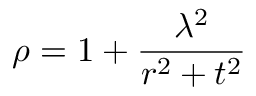Convert formula to latex. <formula><loc_0><loc_0><loc_500><loc_500>\rho = 1 + \frac { \lambda ^ { 2 } } { r ^ { 2 } + t ^ { 2 } }</formula> 